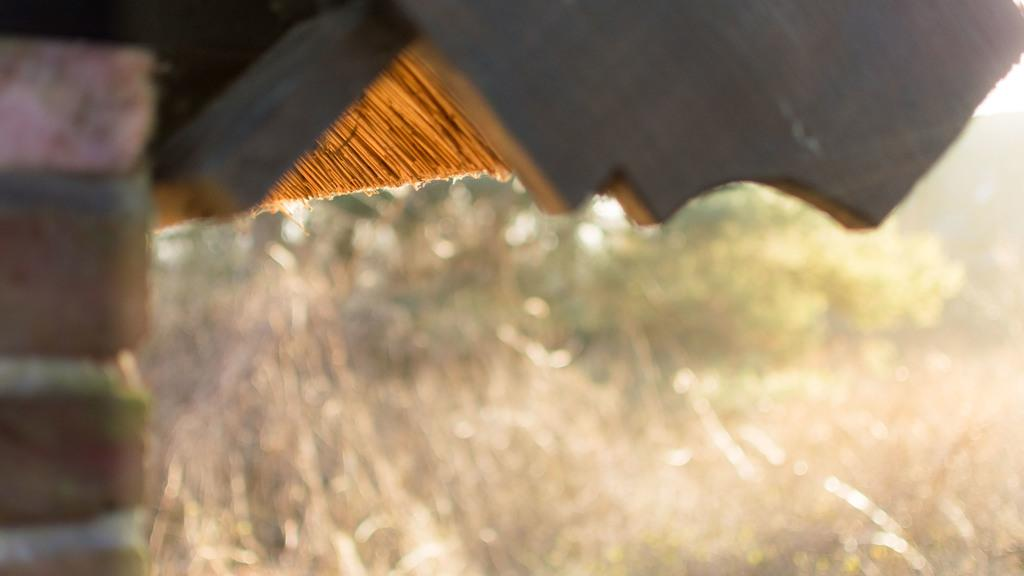What type of house is on the left side of the image? There is a house with red bricks on the left side of the image. What can be seen on the right side of the image? There is dry grass and trees on the right side of the image. Is there a lake visible in the image? No, there is no lake present in the image. What trick is being played on the house in the image? There is no trick being played on the house in the image; it is a regular house with red bricks. 